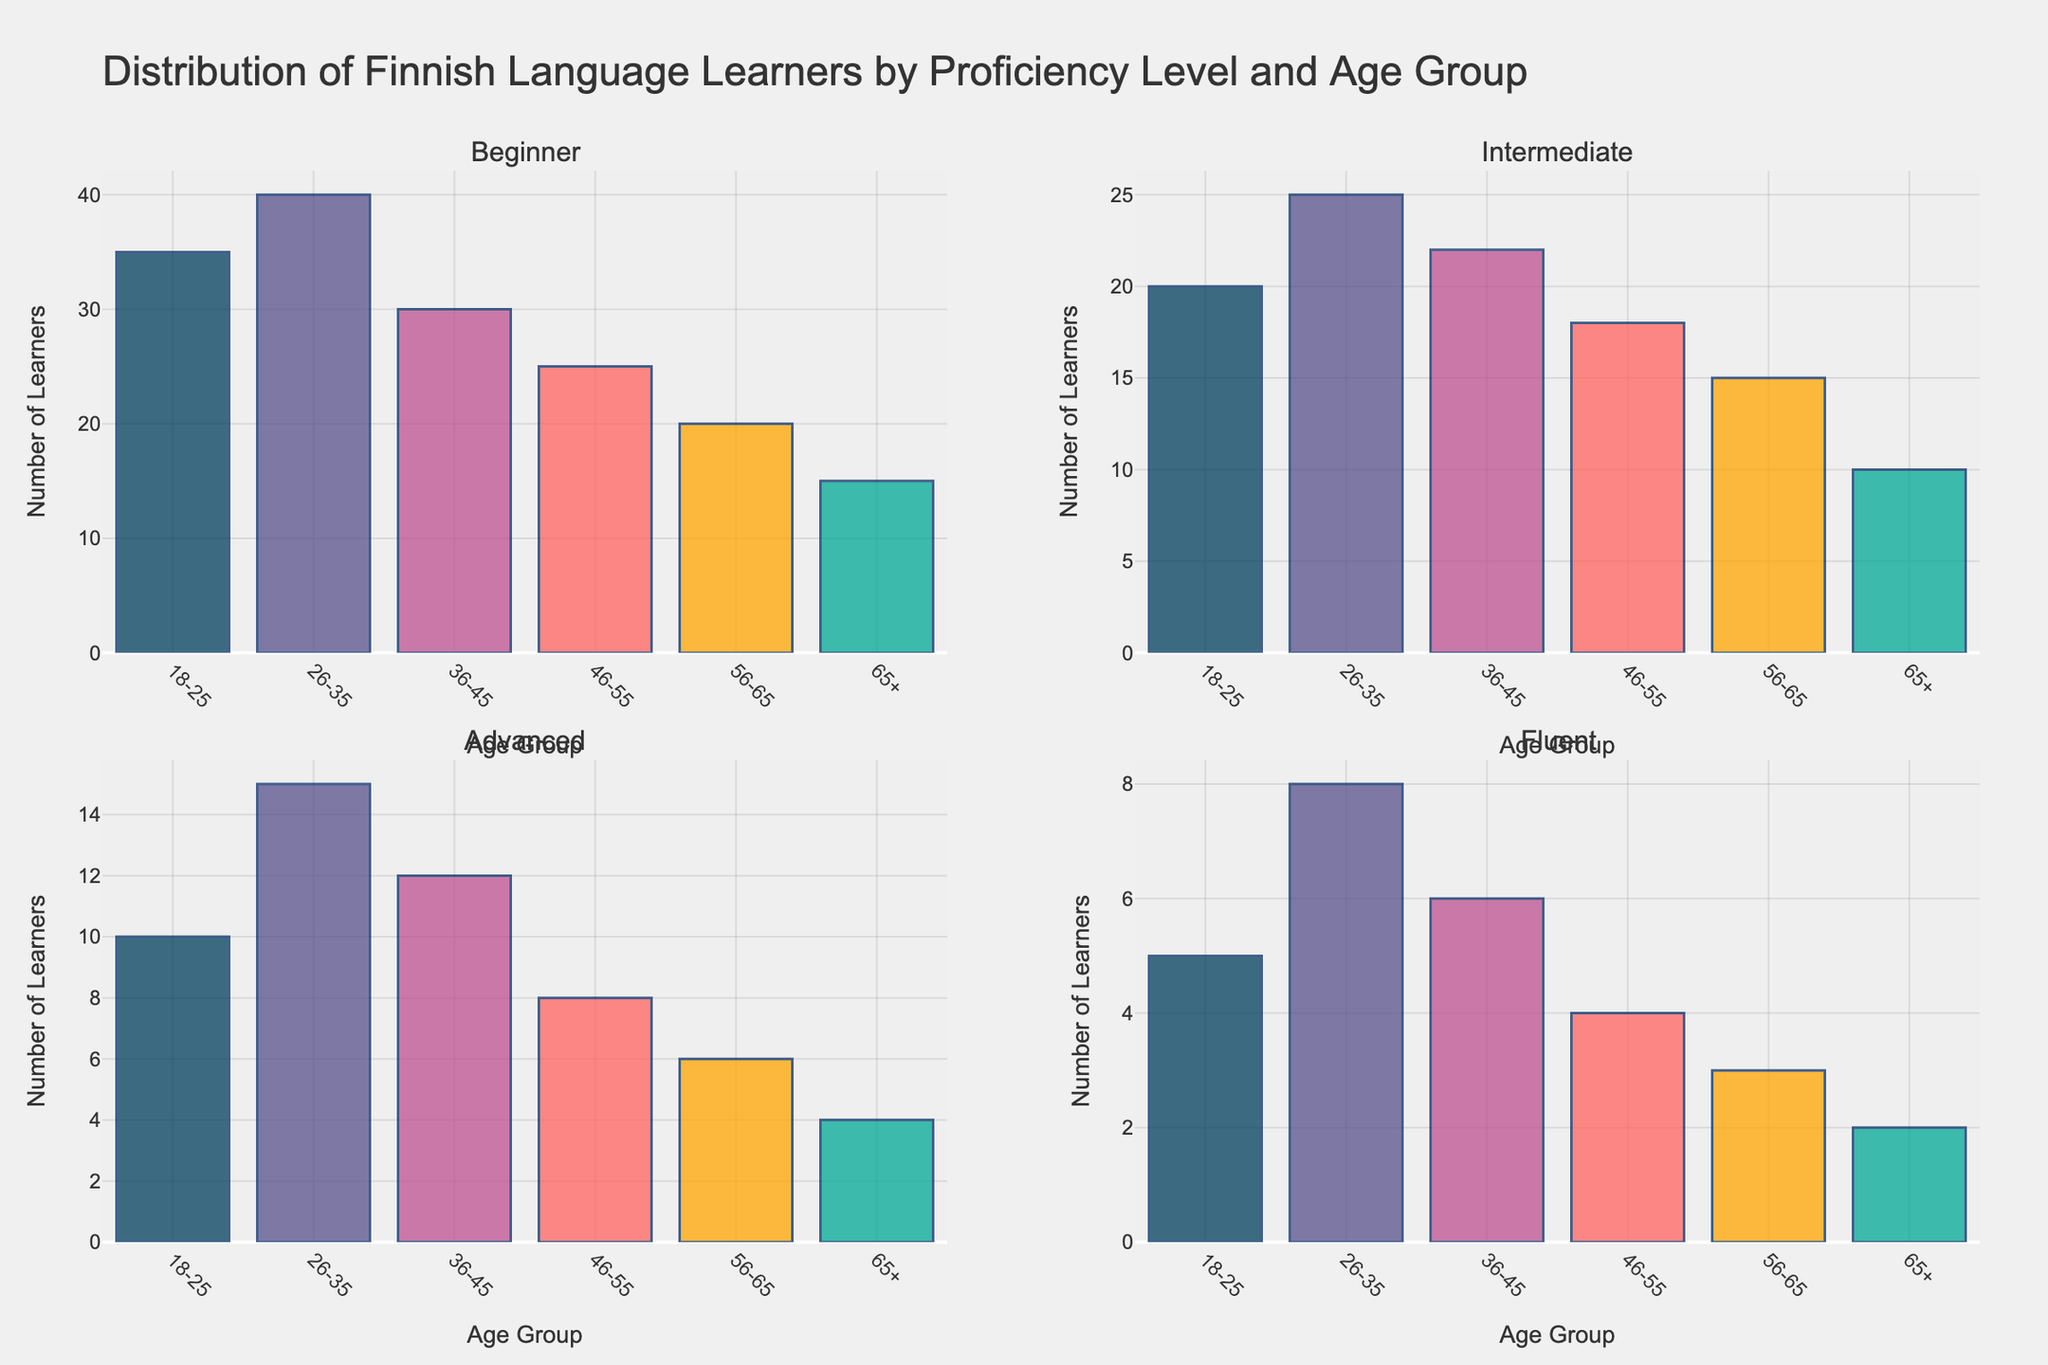what's the title of the figure? The title can be found at the top of the figure.
Answer: Distribution of Finnish Language Learners by Proficiency Level and Age Group which proficiency level has the most learners across all age groups? By visually comparing the heights of the bars in each subplot, the 'Beginner' level consistently has higher bar heights.
Answer: Beginner how many learners are in the 36-45 age group for the Intermediate level? Look at the bar for the 36-45 age group in the Intermediate subplot to find the number.
Answer: 22 how does the number of advanced learners in the 26-35 age group compare to the number of advanced learners in the 46-55 age group? Look at the heights of the bars in the Advanced subplot for the respective age groups. The 26-35 age group bar is taller.
Answer: More in 26-35 which age group has the lowest number of fluent learners? In the Fluent subplot, find the shortest bar and note the age group it represents.
Answer: 65+ what's the total number of learners in the 18-25 age group across all proficiency levels? Add the values of the 18-25 age group from each subplot: 35 + 20 + 10 + 5.
Answer: 70 what's the average number of intermediate learners across all age groups? Sum the values for Intermediate across all age groups and divide by the number of age groups: (20 + 25 + 22 + 18 + 15 + 10) / 6.
Answer: 18.33 what's the difference in the number of beginner learners between the 18-25 and 65+ age groups? Subtract the value of the 65+ group from the 18-25 group for Beginner learners: 35 - 15.
Answer: 20 are there more fluent learners in the 26-35 age group than advanced learners in the 36-45 age group? Compare the height of the Fluent bar for 26-35 with the height of the Advanced bar for 36-45. The Advanced bar is taller.
Answer: No which proficiency level shows the largest decrease in learners from the 18-25 age group to the 65+ age group? Compare the decrease in heights from 18-25 to 65+ across all subplots. The largest drop is in the Beginner subgroup.
Answer: Beginner 